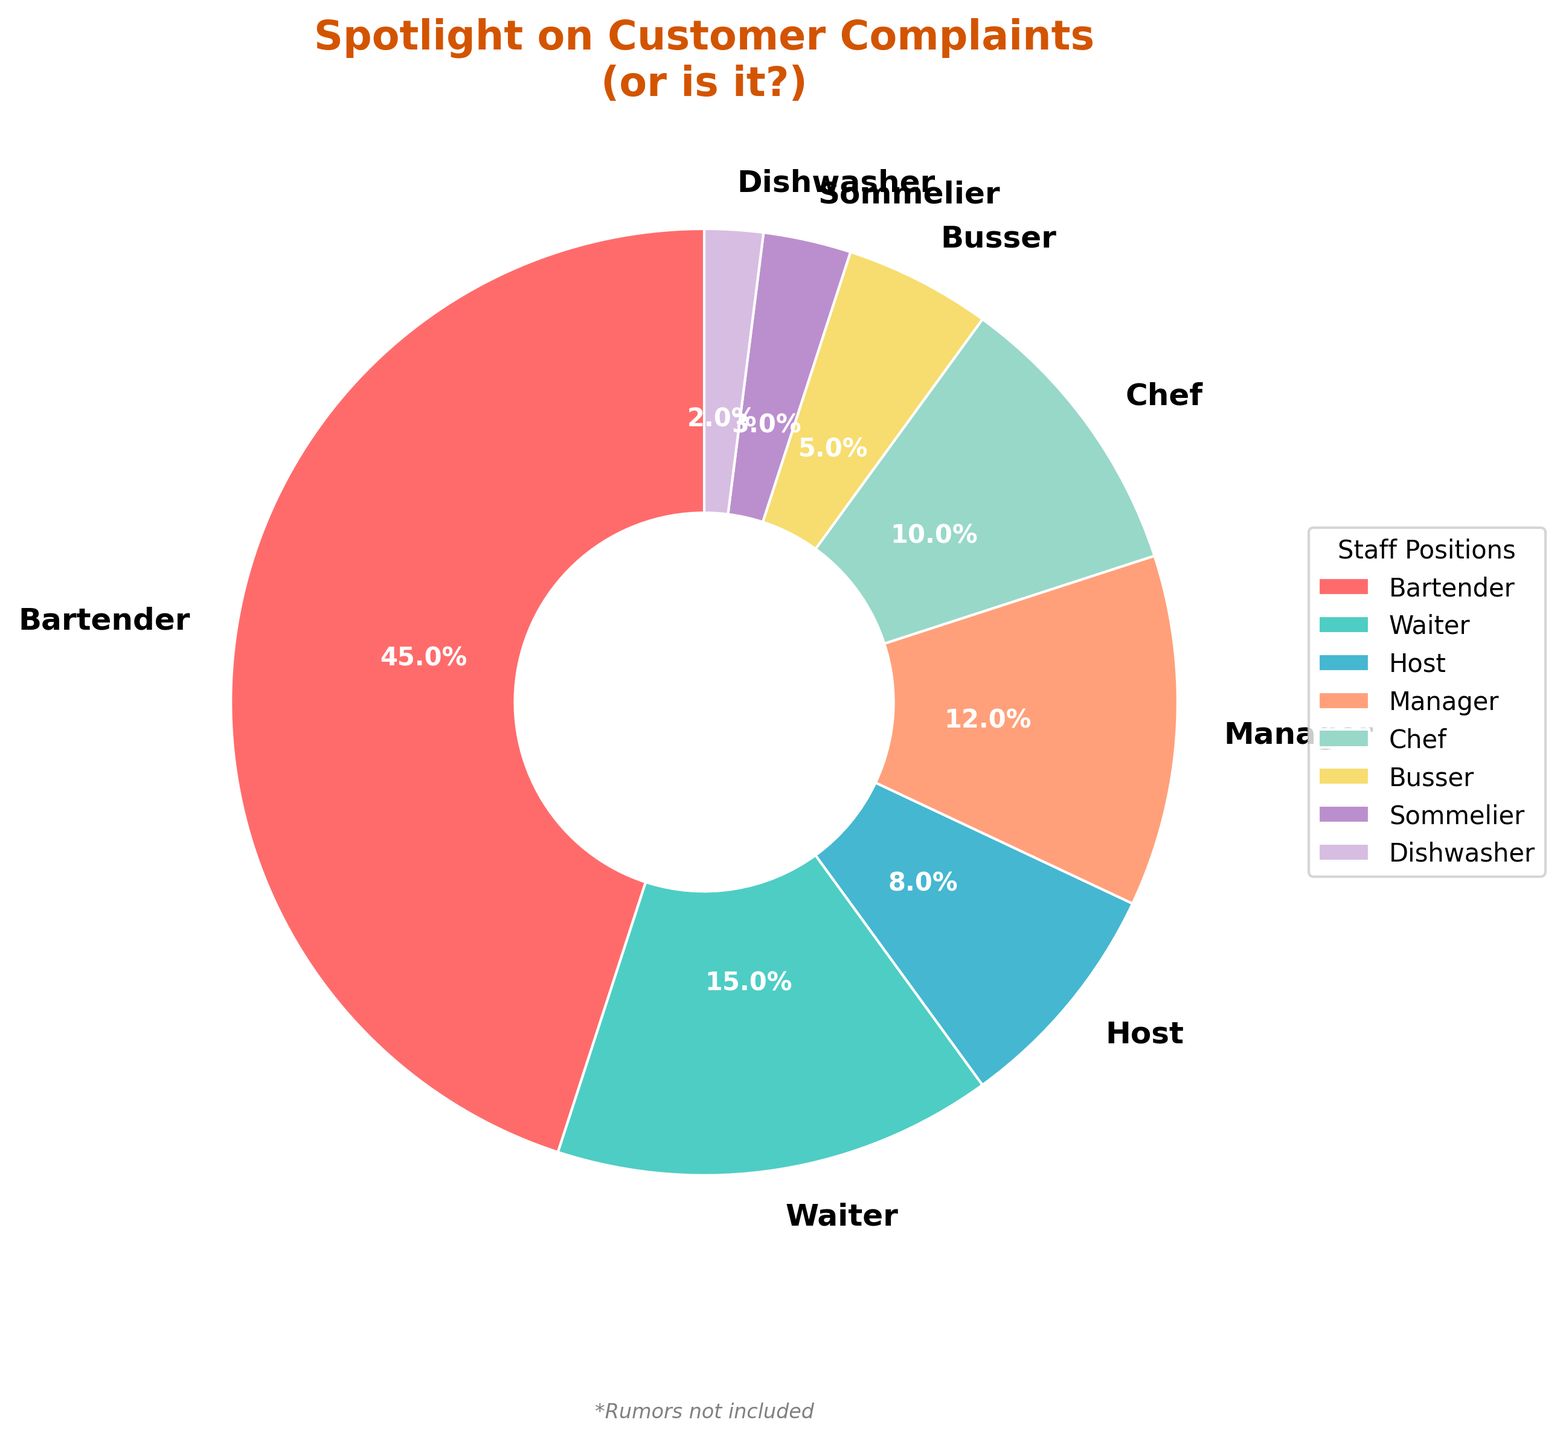What is the percentage of complaints for the bartender? Locate the bartender slice in the pie chart, which is one of the largest slices. The percentage is labeled directly on this slice.
Answer: 45% What is the total percentage of complaints attributed to the waiter and the manager combined? Find the waiter and manager slices in the pie chart and add their percentages together. The waiter has 15% and the manager has 12%. Summing these gives 15% + 12% = 27%.
Answer: 27% How does the number of complaints against the chef compare to those against the host? Identify the chef's and the host's slices in the chart. The chef has complaints equivalent to 10% and the host to 8%. The chef has 2% more complaints than the host.
Answer: More complaints What percentage of the total complaints are lodged against the busser and the dishwasher together? Locate the busser and the dishwasher slices in the chart. The percentages for these positions are 5% and 2% respectively. Adding these together gives 5% + 2% = 7%.
Answer: 7% Which staff position has the fewest complaints? Examine the pie chart and locate the smallest slice. The label indicates it is the Dishwasher position with 2% of the complaints.
Answer: Dishwasher If we add the complaints of the positions with the three highest percentages, what is the total? Identify the three largest slices in the chart: Bartender (45%), Waiter (15%), and Manager (12%). Adding them together gives 45% + 15% + 12% = 72%.
Answer: 72% Which slice is visually the largest on the pie chart and what could this imply about customer sentiment? Observe the largest slice in the chart, which belongs to the Bartender with 45% of complaints. This suggests that customers have the most complaints against bartenders.
Answer: Bartender, 45% What visual clue can you find that indicates the percentage amount for the chef's complaints? Look for the chef's slice, and observe the text label marking it. It indicates the chef has 10% of the complaints.
Answer: 10% How many slices in total represent the breakdown of customer complaints? Count the total number of slices within the pie chart. Each slice corresponds to a different staff position. There are 8 slices in total.
Answer: 8 Between the sommelier and the host, who receives more customer complaints and by what percentage difference? Compare the sommelier slice (3%) to the host slice (8%). The host receives more complaints with a difference of 8% - 3% = 5%.
Answer: Host, 5% 